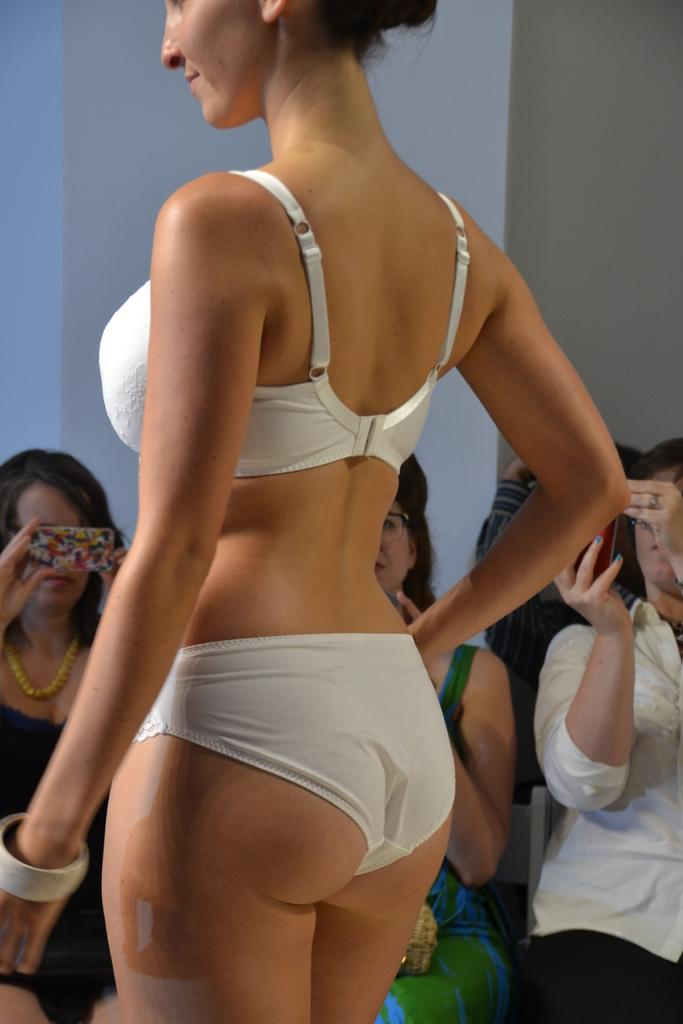Who is the main subject in the image? There is a girl in the image. What is the girl wearing? The girl is wearing a bikini. What are the people in the background doing? The people in the background are taking pictures with a camera. What type of oatmeal is being served to the dolls in the image? There are no dolls or oatmeal present in the image. 